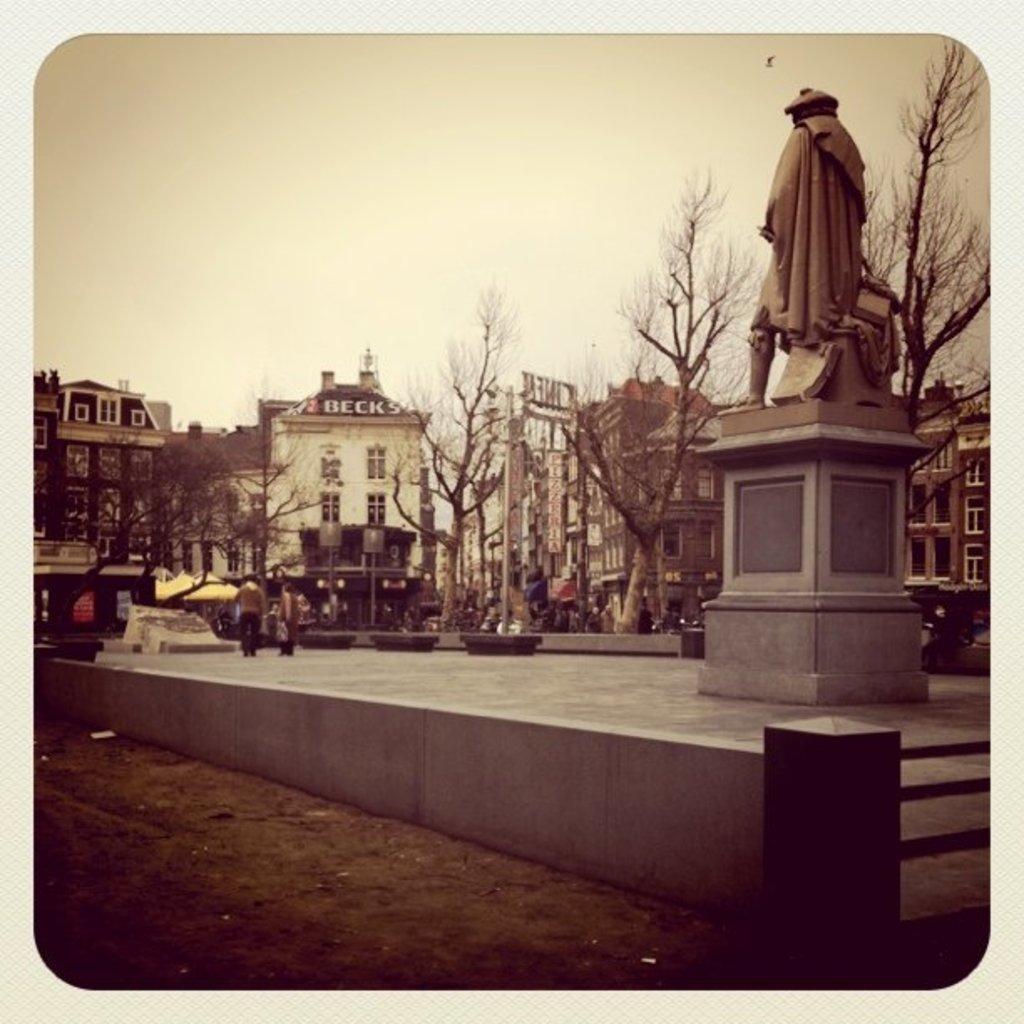Describe this image in one or two sentences. In this picture we can see a statue on a platform, here we can see people, benches on the stage, beside this stage we can see the ground and in the background we can see buildings, trees, sky and some objects. 